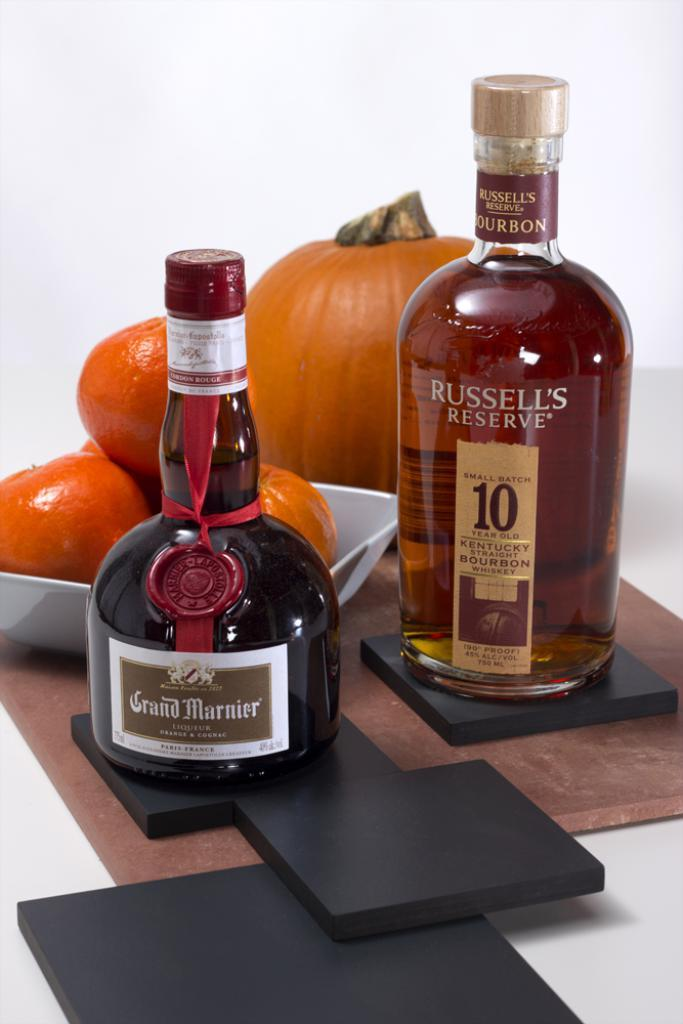What type of beverage containers are present in the image? There are two alcohol bottles in the image. What is the color of the table on which the alcohol bottles are placed? The table is black in color. What type of fruit can be seen in the image? There is a bowl containing oranges in the image. What is the color of the pad on which the bowl of oranges is placed? The pad is brown in color. What additional object is placed on the brown color pad? There is a pumpkin placed on the brown color pad. What type of calendar is hanging on the wall in the image? There is no calendar present in the image. What type of office equipment can be seen in the image? There is no office equipment present in the image. 